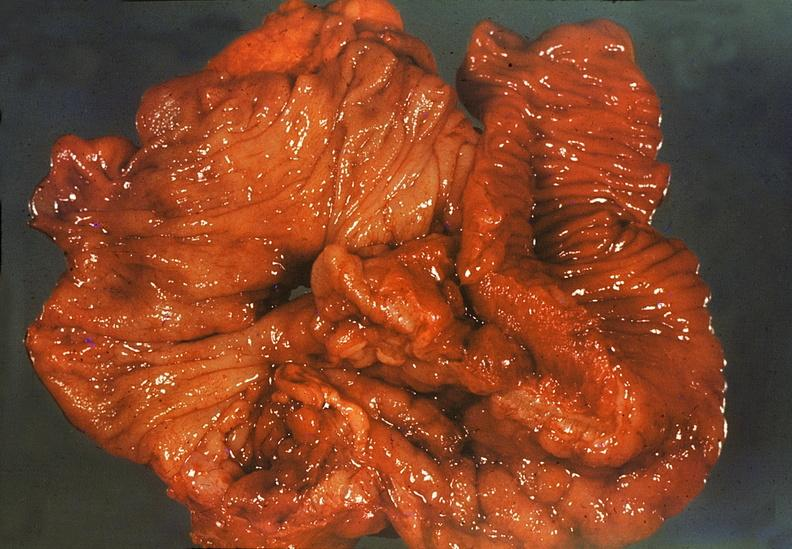what is present?
Answer the question using a single word or phrase. Gastrointestinal 